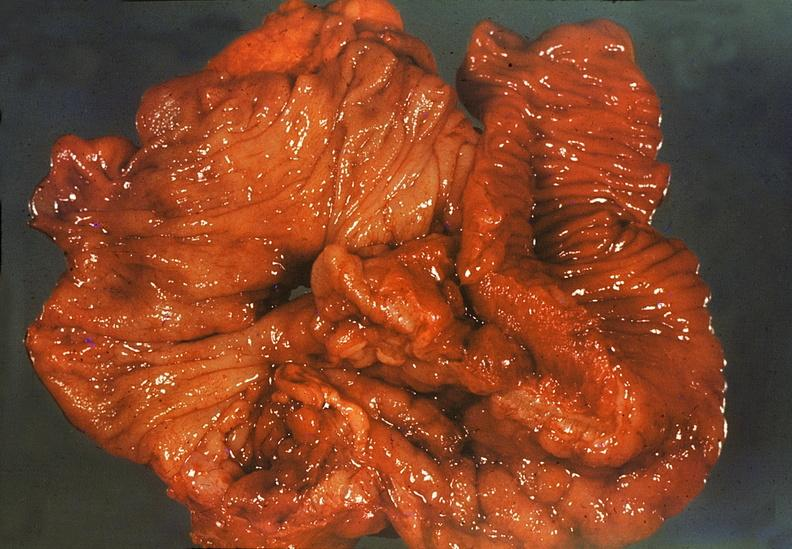what is present?
Answer the question using a single word or phrase. Gastrointestinal 